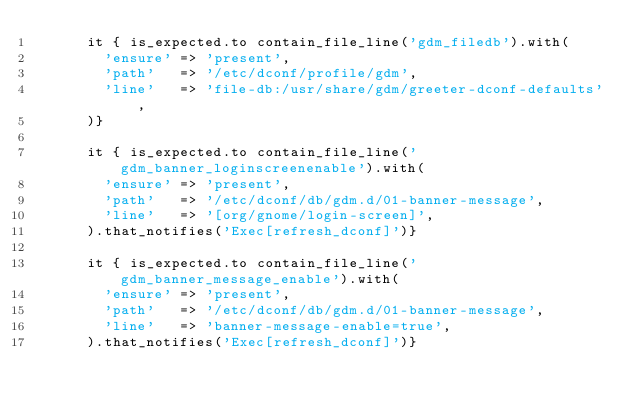<code> <loc_0><loc_0><loc_500><loc_500><_Ruby_>      it { is_expected.to contain_file_line('gdm_filedb').with(
        'ensure' => 'present',
        'path'   => '/etc/dconf/profile/gdm',
        'line'   => 'file-db:/usr/share/gdm/greeter-dconf-defaults',
      )}

      it { is_expected.to contain_file_line('gdm_banner_loginscreenenable').with(
        'ensure' => 'present',
        'path'   => '/etc/dconf/db/gdm.d/01-banner-message',
        'line'   => '[org/gnome/login-screen]',
      ).that_notifies('Exec[refresh_dconf]')}

      it { is_expected.to contain_file_line('gdm_banner_message_enable').with(
        'ensure' => 'present',
        'path'   => '/etc/dconf/db/gdm.d/01-banner-message',
        'line'   => 'banner-message-enable=true',
      ).that_notifies('Exec[refresh_dconf]')}
</code> 